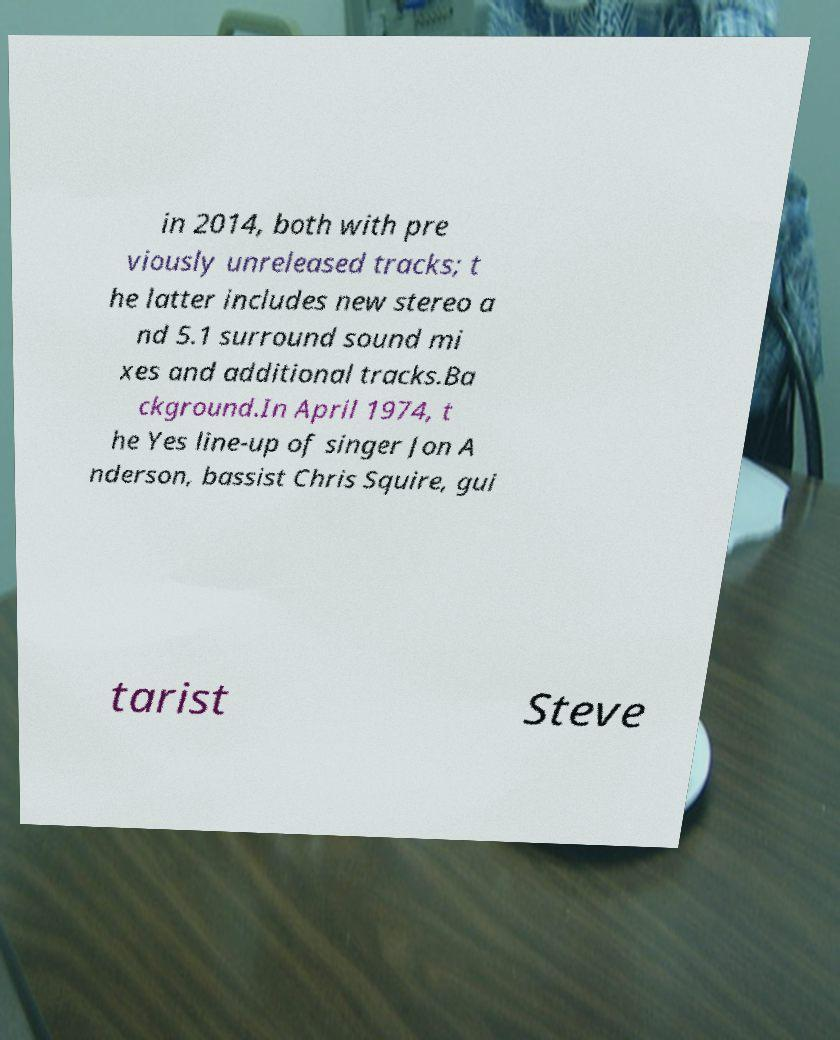What messages or text are displayed in this image? I need them in a readable, typed format. in 2014, both with pre viously unreleased tracks; t he latter includes new stereo a nd 5.1 surround sound mi xes and additional tracks.Ba ckground.In April 1974, t he Yes line-up of singer Jon A nderson, bassist Chris Squire, gui tarist Steve 